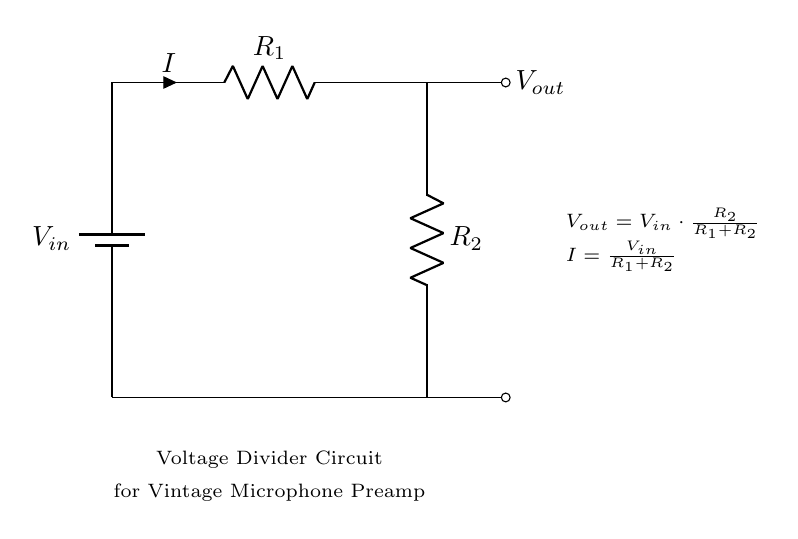What is the type of circuit shown? The circuit is a voltage divider circuit, indicated by the specific arrangement of resistors being used to divide the input voltage.
Answer: Voltage divider What are the components used in this circuit? The circuit consists of a battery and two resistors, denoted R1 and R2. The battery provides the input voltage, and the resistors are responsible for dividing the voltage.
Answer: Battery, R1, R2 What is the formula for the output voltage? The formula for the output voltage (Vout) is provided in the diagram as Vout = Vin * (R2 / (R1 + R2)), which combines the input voltage and the resistance values to calculate the output voltage.
Answer: Vout = Vin * (R2 / (R1 + R2)) What is the current in the circuit? The current (I) is defined by the equation I = Vin / (R1 + R2), which shows how the total input voltage is divided by the total resistance to find the current flowing through the circuit.
Answer: I = Vin / (R1 + R2) What happens to the output voltage if R1 is increased? Increasing R1 decreases the output voltage, as this will affect the ratio R2/(R1 + R2) in the voltage divider formula, leading to a smaller fraction of Vin being output.
Answer: Decreases How does the voltage divider affect microphone input? The voltage divider adjusts the signal level for the microphone preamplifier, ensuring that the microphone receives the appropriate voltage level for optimal signal processing without distortion.
Answer: Adjusts signal level What is the purpose of R2 in this circuit? R2 is crucial in the voltage divider operation as it controls the amount of output voltage relative to the input, allowing for voltage scaling which is essential for matching the input sensitivity of subsequent circuit stages.
Answer: Controls output voltage 